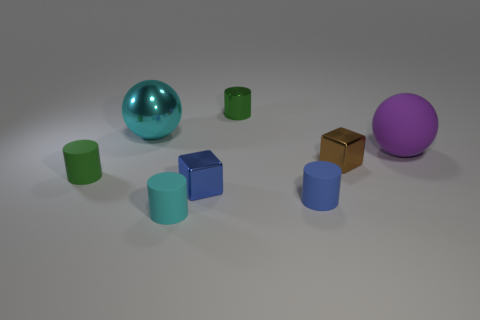Is there another small cube that has the same material as the small brown block?
Give a very brief answer. Yes. There is a big ball on the right side of the small brown cube; is there a metallic object right of it?
Your answer should be compact. No. There is a shiny cube right of the blue rubber object; does it have the same size as the purple matte object?
Make the answer very short. No. The shiny ball has what size?
Keep it short and to the point. Large. Are there any tiny metal cylinders of the same color as the big matte ball?
Your response must be concise. No. What number of tiny things are either cyan metallic spheres or brown blocks?
Your answer should be compact. 1. There is a thing that is behind the tiny brown metallic object and in front of the large metallic ball; how big is it?
Give a very brief answer. Large. How many small green shiny cylinders are in front of the big metallic object?
Keep it short and to the point. 0. There is a matte thing that is on the right side of the small cyan cylinder and to the left of the tiny brown cube; what is its shape?
Keep it short and to the point. Cylinder. There is a small object that is the same color as the metallic cylinder; what material is it?
Offer a very short reply. Rubber. 